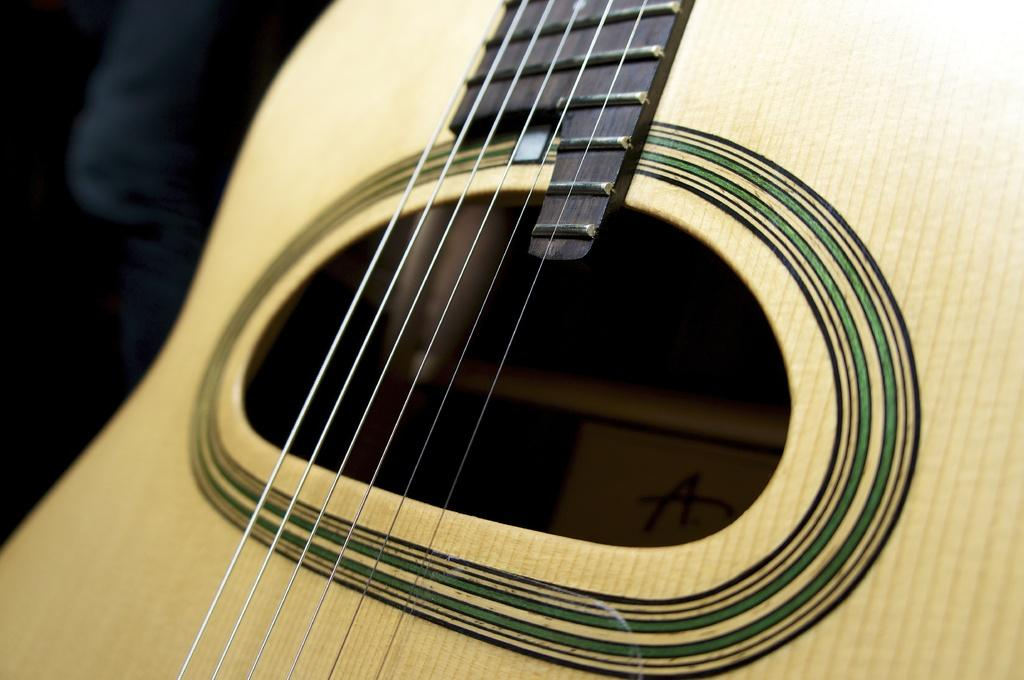What musical instrument is present in the image? There is a guitar in the image. What feature of the guitar is mentioned in the facts? The guitar has strings. What type of pest can be seen crawling on the guitar in the image? There is no pest present on the guitar in the image. Is there an advertisement for a clock on the guitar in the image? There is no advertisement or mention of a clock in the image. 